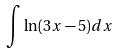<formula> <loc_0><loc_0><loc_500><loc_500>\int \ln ( 3 x - 5 ) d x</formula> 